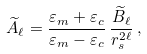Convert formula to latex. <formula><loc_0><loc_0><loc_500><loc_500>\widetilde { A } _ { \ell } = \frac { \varepsilon _ { m } + \varepsilon _ { c } } { \varepsilon _ { m } - \varepsilon _ { c } } \, \frac { \widetilde { B } _ { \ell } } { r _ { s } ^ { 2 \ell } } \, ,</formula> 